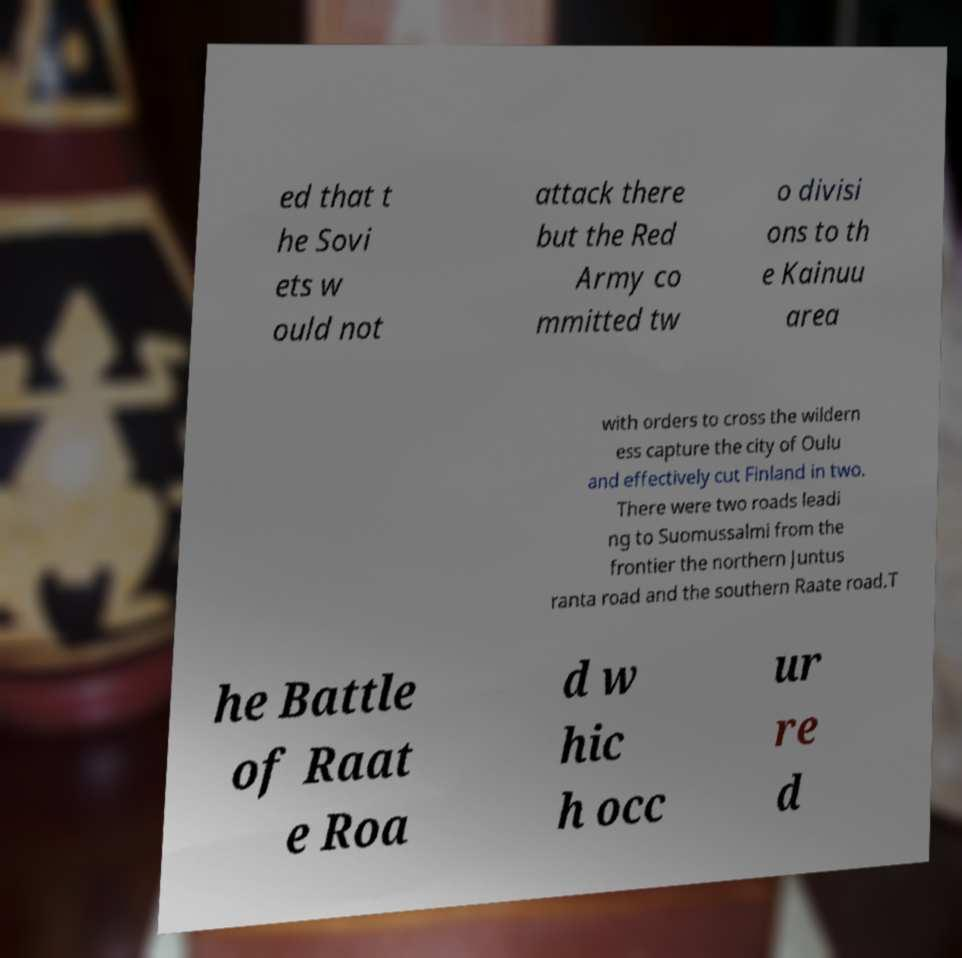What messages or text are displayed in this image? I need them in a readable, typed format. ed that t he Sovi ets w ould not attack there but the Red Army co mmitted tw o divisi ons to th e Kainuu area with orders to cross the wildern ess capture the city of Oulu and effectively cut Finland in two. There were two roads leadi ng to Suomussalmi from the frontier the northern Juntus ranta road and the southern Raate road.T he Battle of Raat e Roa d w hic h occ ur re d 